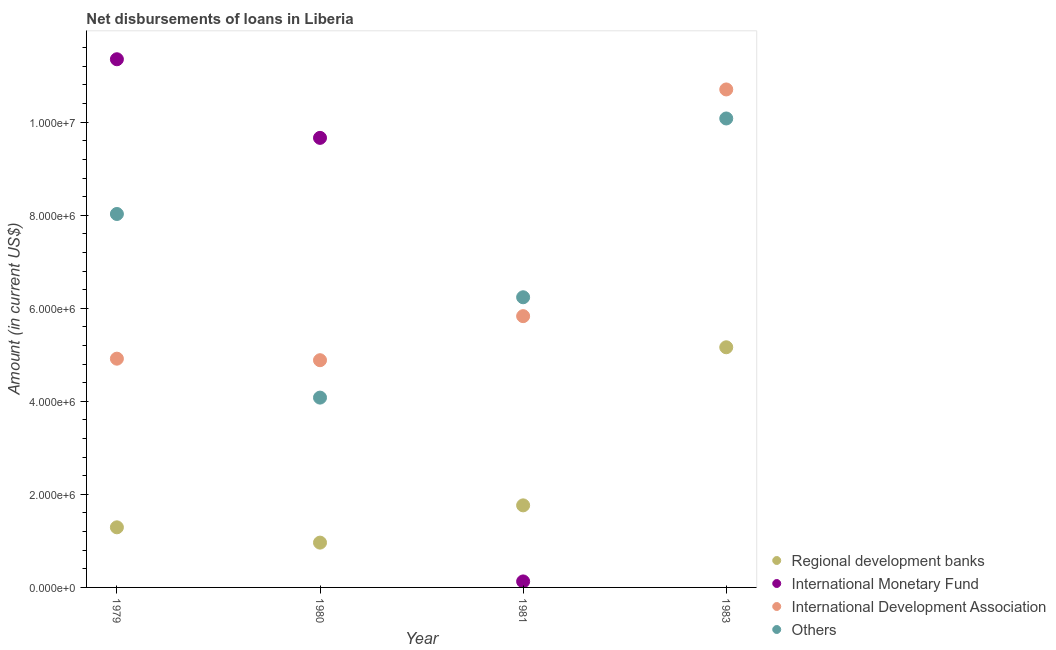Is the number of dotlines equal to the number of legend labels?
Provide a short and direct response. No. What is the amount of loan disimbursed by other organisations in 1981?
Make the answer very short. 6.24e+06. Across all years, what is the maximum amount of loan disimbursed by other organisations?
Provide a short and direct response. 1.01e+07. Across all years, what is the minimum amount of loan disimbursed by international development association?
Provide a short and direct response. 4.88e+06. What is the total amount of loan disimbursed by regional development banks in the graph?
Provide a short and direct response. 9.18e+06. What is the difference between the amount of loan disimbursed by international development association in 1979 and that in 1980?
Your response must be concise. 3.30e+04. What is the difference between the amount of loan disimbursed by other organisations in 1981 and the amount of loan disimbursed by international development association in 1983?
Make the answer very short. -4.47e+06. What is the average amount of loan disimbursed by regional development banks per year?
Your answer should be very brief. 2.30e+06. In the year 1981, what is the difference between the amount of loan disimbursed by regional development banks and amount of loan disimbursed by other organisations?
Make the answer very short. -4.47e+06. What is the ratio of the amount of loan disimbursed by other organisations in 1980 to that in 1981?
Provide a succinct answer. 0.65. Is the amount of loan disimbursed by regional development banks in 1979 less than that in 1981?
Your answer should be very brief. Yes. Is the difference between the amount of loan disimbursed by other organisations in 1980 and 1981 greater than the difference between the amount of loan disimbursed by international monetary fund in 1980 and 1981?
Make the answer very short. No. What is the difference between the highest and the second highest amount of loan disimbursed by international monetary fund?
Your response must be concise. 1.69e+06. What is the difference between the highest and the lowest amount of loan disimbursed by international development association?
Offer a terse response. 5.82e+06. In how many years, is the amount of loan disimbursed by other organisations greater than the average amount of loan disimbursed by other organisations taken over all years?
Make the answer very short. 2. Is it the case that in every year, the sum of the amount of loan disimbursed by international development association and amount of loan disimbursed by regional development banks is greater than the sum of amount of loan disimbursed by international monetary fund and amount of loan disimbursed by other organisations?
Provide a succinct answer. No. Does the amount of loan disimbursed by other organisations monotonically increase over the years?
Your answer should be very brief. No. What is the difference between two consecutive major ticks on the Y-axis?
Offer a very short reply. 2.00e+06. How are the legend labels stacked?
Offer a very short reply. Vertical. What is the title of the graph?
Provide a succinct answer. Net disbursements of loans in Liberia. Does "Subsidies and Transfers" appear as one of the legend labels in the graph?
Your response must be concise. No. What is the label or title of the X-axis?
Give a very brief answer. Year. What is the Amount (in current US$) of Regional development banks in 1979?
Your answer should be very brief. 1.29e+06. What is the Amount (in current US$) in International Monetary Fund in 1979?
Offer a terse response. 1.14e+07. What is the Amount (in current US$) of International Development Association in 1979?
Your answer should be very brief. 4.92e+06. What is the Amount (in current US$) of Others in 1979?
Ensure brevity in your answer.  8.03e+06. What is the Amount (in current US$) in Regional development banks in 1980?
Make the answer very short. 9.63e+05. What is the Amount (in current US$) in International Monetary Fund in 1980?
Provide a short and direct response. 9.66e+06. What is the Amount (in current US$) in International Development Association in 1980?
Provide a short and direct response. 4.88e+06. What is the Amount (in current US$) in Others in 1980?
Give a very brief answer. 4.08e+06. What is the Amount (in current US$) in Regional development banks in 1981?
Make the answer very short. 1.76e+06. What is the Amount (in current US$) in International Monetary Fund in 1981?
Your response must be concise. 1.29e+05. What is the Amount (in current US$) of International Development Association in 1981?
Your answer should be compact. 5.83e+06. What is the Amount (in current US$) of Others in 1981?
Keep it short and to the point. 6.24e+06. What is the Amount (in current US$) of Regional development banks in 1983?
Make the answer very short. 5.16e+06. What is the Amount (in current US$) of International Monetary Fund in 1983?
Ensure brevity in your answer.  0. What is the Amount (in current US$) of International Development Association in 1983?
Your answer should be compact. 1.07e+07. What is the Amount (in current US$) in Others in 1983?
Give a very brief answer. 1.01e+07. Across all years, what is the maximum Amount (in current US$) of Regional development banks?
Make the answer very short. 5.16e+06. Across all years, what is the maximum Amount (in current US$) of International Monetary Fund?
Keep it short and to the point. 1.14e+07. Across all years, what is the maximum Amount (in current US$) in International Development Association?
Provide a short and direct response. 1.07e+07. Across all years, what is the maximum Amount (in current US$) of Others?
Keep it short and to the point. 1.01e+07. Across all years, what is the minimum Amount (in current US$) of Regional development banks?
Your answer should be compact. 9.63e+05. Across all years, what is the minimum Amount (in current US$) in International Development Association?
Keep it short and to the point. 4.88e+06. Across all years, what is the minimum Amount (in current US$) in Others?
Provide a succinct answer. 4.08e+06. What is the total Amount (in current US$) of Regional development banks in the graph?
Offer a terse response. 9.18e+06. What is the total Amount (in current US$) of International Monetary Fund in the graph?
Provide a succinct answer. 2.11e+07. What is the total Amount (in current US$) in International Development Association in the graph?
Your answer should be compact. 2.63e+07. What is the total Amount (in current US$) of Others in the graph?
Offer a very short reply. 2.84e+07. What is the difference between the Amount (in current US$) in Regional development banks in 1979 and that in 1980?
Your response must be concise. 3.29e+05. What is the difference between the Amount (in current US$) of International Monetary Fund in 1979 and that in 1980?
Provide a succinct answer. 1.69e+06. What is the difference between the Amount (in current US$) of International Development Association in 1979 and that in 1980?
Make the answer very short. 3.30e+04. What is the difference between the Amount (in current US$) of Others in 1979 and that in 1980?
Ensure brevity in your answer.  3.95e+06. What is the difference between the Amount (in current US$) of Regional development banks in 1979 and that in 1981?
Offer a terse response. -4.72e+05. What is the difference between the Amount (in current US$) in International Monetary Fund in 1979 and that in 1981?
Provide a succinct answer. 1.12e+07. What is the difference between the Amount (in current US$) in International Development Association in 1979 and that in 1981?
Your answer should be very brief. -9.14e+05. What is the difference between the Amount (in current US$) of Others in 1979 and that in 1981?
Your answer should be compact. 1.79e+06. What is the difference between the Amount (in current US$) of Regional development banks in 1979 and that in 1983?
Offer a terse response. -3.87e+06. What is the difference between the Amount (in current US$) in International Development Association in 1979 and that in 1983?
Keep it short and to the point. -5.79e+06. What is the difference between the Amount (in current US$) in Others in 1979 and that in 1983?
Offer a terse response. -2.05e+06. What is the difference between the Amount (in current US$) in Regional development banks in 1980 and that in 1981?
Ensure brevity in your answer.  -8.01e+05. What is the difference between the Amount (in current US$) of International Monetary Fund in 1980 and that in 1981?
Make the answer very short. 9.53e+06. What is the difference between the Amount (in current US$) of International Development Association in 1980 and that in 1981?
Provide a short and direct response. -9.47e+05. What is the difference between the Amount (in current US$) in Others in 1980 and that in 1981?
Your answer should be very brief. -2.16e+06. What is the difference between the Amount (in current US$) in Regional development banks in 1980 and that in 1983?
Your answer should be compact. -4.20e+06. What is the difference between the Amount (in current US$) of International Development Association in 1980 and that in 1983?
Make the answer very short. -5.82e+06. What is the difference between the Amount (in current US$) of Others in 1980 and that in 1983?
Your answer should be very brief. -6.00e+06. What is the difference between the Amount (in current US$) in Regional development banks in 1981 and that in 1983?
Your response must be concise. -3.40e+06. What is the difference between the Amount (in current US$) of International Development Association in 1981 and that in 1983?
Give a very brief answer. -4.87e+06. What is the difference between the Amount (in current US$) in Others in 1981 and that in 1983?
Your response must be concise. -3.84e+06. What is the difference between the Amount (in current US$) in Regional development banks in 1979 and the Amount (in current US$) in International Monetary Fund in 1980?
Provide a succinct answer. -8.37e+06. What is the difference between the Amount (in current US$) of Regional development banks in 1979 and the Amount (in current US$) of International Development Association in 1980?
Your response must be concise. -3.59e+06. What is the difference between the Amount (in current US$) in Regional development banks in 1979 and the Amount (in current US$) in Others in 1980?
Offer a very short reply. -2.79e+06. What is the difference between the Amount (in current US$) of International Monetary Fund in 1979 and the Amount (in current US$) of International Development Association in 1980?
Your answer should be compact. 6.47e+06. What is the difference between the Amount (in current US$) of International Monetary Fund in 1979 and the Amount (in current US$) of Others in 1980?
Your answer should be compact. 7.27e+06. What is the difference between the Amount (in current US$) of International Development Association in 1979 and the Amount (in current US$) of Others in 1980?
Make the answer very short. 8.37e+05. What is the difference between the Amount (in current US$) of Regional development banks in 1979 and the Amount (in current US$) of International Monetary Fund in 1981?
Make the answer very short. 1.16e+06. What is the difference between the Amount (in current US$) in Regional development banks in 1979 and the Amount (in current US$) in International Development Association in 1981?
Offer a terse response. -4.54e+06. What is the difference between the Amount (in current US$) of Regional development banks in 1979 and the Amount (in current US$) of Others in 1981?
Provide a succinct answer. -4.94e+06. What is the difference between the Amount (in current US$) in International Monetary Fund in 1979 and the Amount (in current US$) in International Development Association in 1981?
Keep it short and to the point. 5.52e+06. What is the difference between the Amount (in current US$) of International Monetary Fund in 1979 and the Amount (in current US$) of Others in 1981?
Ensure brevity in your answer.  5.12e+06. What is the difference between the Amount (in current US$) in International Development Association in 1979 and the Amount (in current US$) in Others in 1981?
Your answer should be compact. -1.32e+06. What is the difference between the Amount (in current US$) in Regional development banks in 1979 and the Amount (in current US$) in International Development Association in 1983?
Keep it short and to the point. -9.41e+06. What is the difference between the Amount (in current US$) of Regional development banks in 1979 and the Amount (in current US$) of Others in 1983?
Offer a very short reply. -8.79e+06. What is the difference between the Amount (in current US$) of International Monetary Fund in 1979 and the Amount (in current US$) of International Development Association in 1983?
Ensure brevity in your answer.  6.49e+05. What is the difference between the Amount (in current US$) of International Monetary Fund in 1979 and the Amount (in current US$) of Others in 1983?
Your response must be concise. 1.27e+06. What is the difference between the Amount (in current US$) in International Development Association in 1979 and the Amount (in current US$) in Others in 1983?
Give a very brief answer. -5.16e+06. What is the difference between the Amount (in current US$) of Regional development banks in 1980 and the Amount (in current US$) of International Monetary Fund in 1981?
Keep it short and to the point. 8.34e+05. What is the difference between the Amount (in current US$) in Regional development banks in 1980 and the Amount (in current US$) in International Development Association in 1981?
Ensure brevity in your answer.  -4.87e+06. What is the difference between the Amount (in current US$) of Regional development banks in 1980 and the Amount (in current US$) of Others in 1981?
Your answer should be compact. -5.27e+06. What is the difference between the Amount (in current US$) of International Monetary Fund in 1980 and the Amount (in current US$) of International Development Association in 1981?
Provide a short and direct response. 3.83e+06. What is the difference between the Amount (in current US$) in International Monetary Fund in 1980 and the Amount (in current US$) in Others in 1981?
Provide a succinct answer. 3.43e+06. What is the difference between the Amount (in current US$) in International Development Association in 1980 and the Amount (in current US$) in Others in 1981?
Ensure brevity in your answer.  -1.35e+06. What is the difference between the Amount (in current US$) of Regional development banks in 1980 and the Amount (in current US$) of International Development Association in 1983?
Make the answer very short. -9.74e+06. What is the difference between the Amount (in current US$) in Regional development banks in 1980 and the Amount (in current US$) in Others in 1983?
Provide a short and direct response. -9.12e+06. What is the difference between the Amount (in current US$) in International Monetary Fund in 1980 and the Amount (in current US$) in International Development Association in 1983?
Your answer should be very brief. -1.04e+06. What is the difference between the Amount (in current US$) in International Monetary Fund in 1980 and the Amount (in current US$) in Others in 1983?
Your answer should be compact. -4.17e+05. What is the difference between the Amount (in current US$) in International Development Association in 1980 and the Amount (in current US$) in Others in 1983?
Ensure brevity in your answer.  -5.20e+06. What is the difference between the Amount (in current US$) of Regional development banks in 1981 and the Amount (in current US$) of International Development Association in 1983?
Offer a very short reply. -8.94e+06. What is the difference between the Amount (in current US$) in Regional development banks in 1981 and the Amount (in current US$) in Others in 1983?
Offer a very short reply. -8.32e+06. What is the difference between the Amount (in current US$) in International Monetary Fund in 1981 and the Amount (in current US$) in International Development Association in 1983?
Keep it short and to the point. -1.06e+07. What is the difference between the Amount (in current US$) in International Monetary Fund in 1981 and the Amount (in current US$) in Others in 1983?
Provide a succinct answer. -9.95e+06. What is the difference between the Amount (in current US$) in International Development Association in 1981 and the Amount (in current US$) in Others in 1983?
Offer a very short reply. -4.25e+06. What is the average Amount (in current US$) of Regional development banks per year?
Your answer should be compact. 2.30e+06. What is the average Amount (in current US$) in International Monetary Fund per year?
Give a very brief answer. 5.29e+06. What is the average Amount (in current US$) of International Development Association per year?
Your answer should be very brief. 6.58e+06. What is the average Amount (in current US$) of Others per year?
Ensure brevity in your answer.  7.11e+06. In the year 1979, what is the difference between the Amount (in current US$) of Regional development banks and Amount (in current US$) of International Monetary Fund?
Give a very brief answer. -1.01e+07. In the year 1979, what is the difference between the Amount (in current US$) of Regional development banks and Amount (in current US$) of International Development Association?
Provide a succinct answer. -3.62e+06. In the year 1979, what is the difference between the Amount (in current US$) in Regional development banks and Amount (in current US$) in Others?
Offer a terse response. -6.74e+06. In the year 1979, what is the difference between the Amount (in current US$) in International Monetary Fund and Amount (in current US$) in International Development Association?
Provide a short and direct response. 6.44e+06. In the year 1979, what is the difference between the Amount (in current US$) in International Monetary Fund and Amount (in current US$) in Others?
Provide a short and direct response. 3.33e+06. In the year 1979, what is the difference between the Amount (in current US$) of International Development Association and Amount (in current US$) of Others?
Offer a very short reply. -3.11e+06. In the year 1980, what is the difference between the Amount (in current US$) in Regional development banks and Amount (in current US$) in International Monetary Fund?
Make the answer very short. -8.70e+06. In the year 1980, what is the difference between the Amount (in current US$) of Regional development banks and Amount (in current US$) of International Development Association?
Your answer should be very brief. -3.92e+06. In the year 1980, what is the difference between the Amount (in current US$) in Regional development banks and Amount (in current US$) in Others?
Keep it short and to the point. -3.12e+06. In the year 1980, what is the difference between the Amount (in current US$) in International Monetary Fund and Amount (in current US$) in International Development Association?
Provide a succinct answer. 4.78e+06. In the year 1980, what is the difference between the Amount (in current US$) in International Monetary Fund and Amount (in current US$) in Others?
Keep it short and to the point. 5.58e+06. In the year 1980, what is the difference between the Amount (in current US$) in International Development Association and Amount (in current US$) in Others?
Your response must be concise. 8.04e+05. In the year 1981, what is the difference between the Amount (in current US$) of Regional development banks and Amount (in current US$) of International Monetary Fund?
Provide a short and direct response. 1.64e+06. In the year 1981, what is the difference between the Amount (in current US$) in Regional development banks and Amount (in current US$) in International Development Association?
Your response must be concise. -4.07e+06. In the year 1981, what is the difference between the Amount (in current US$) in Regional development banks and Amount (in current US$) in Others?
Keep it short and to the point. -4.47e+06. In the year 1981, what is the difference between the Amount (in current US$) of International Monetary Fund and Amount (in current US$) of International Development Association?
Ensure brevity in your answer.  -5.70e+06. In the year 1981, what is the difference between the Amount (in current US$) of International Monetary Fund and Amount (in current US$) of Others?
Keep it short and to the point. -6.11e+06. In the year 1981, what is the difference between the Amount (in current US$) of International Development Association and Amount (in current US$) of Others?
Your response must be concise. -4.06e+05. In the year 1983, what is the difference between the Amount (in current US$) in Regional development banks and Amount (in current US$) in International Development Association?
Give a very brief answer. -5.54e+06. In the year 1983, what is the difference between the Amount (in current US$) of Regional development banks and Amount (in current US$) of Others?
Offer a terse response. -4.92e+06. In the year 1983, what is the difference between the Amount (in current US$) in International Development Association and Amount (in current US$) in Others?
Make the answer very short. 6.24e+05. What is the ratio of the Amount (in current US$) in Regional development banks in 1979 to that in 1980?
Provide a succinct answer. 1.34. What is the ratio of the Amount (in current US$) of International Monetary Fund in 1979 to that in 1980?
Provide a short and direct response. 1.17. What is the ratio of the Amount (in current US$) of International Development Association in 1979 to that in 1980?
Your answer should be very brief. 1.01. What is the ratio of the Amount (in current US$) in Others in 1979 to that in 1980?
Your answer should be compact. 1.97. What is the ratio of the Amount (in current US$) of Regional development banks in 1979 to that in 1981?
Ensure brevity in your answer.  0.73. What is the ratio of the Amount (in current US$) in International Monetary Fund in 1979 to that in 1981?
Make the answer very short. 88.01. What is the ratio of the Amount (in current US$) of International Development Association in 1979 to that in 1981?
Give a very brief answer. 0.84. What is the ratio of the Amount (in current US$) of Others in 1979 to that in 1981?
Provide a succinct answer. 1.29. What is the ratio of the Amount (in current US$) in Regional development banks in 1979 to that in 1983?
Make the answer very short. 0.25. What is the ratio of the Amount (in current US$) in International Development Association in 1979 to that in 1983?
Make the answer very short. 0.46. What is the ratio of the Amount (in current US$) of Others in 1979 to that in 1983?
Your response must be concise. 0.8. What is the ratio of the Amount (in current US$) in Regional development banks in 1980 to that in 1981?
Your answer should be compact. 0.55. What is the ratio of the Amount (in current US$) of International Monetary Fund in 1980 to that in 1981?
Ensure brevity in your answer.  74.91. What is the ratio of the Amount (in current US$) in International Development Association in 1980 to that in 1981?
Your answer should be compact. 0.84. What is the ratio of the Amount (in current US$) of Others in 1980 to that in 1981?
Give a very brief answer. 0.65. What is the ratio of the Amount (in current US$) of Regional development banks in 1980 to that in 1983?
Provide a short and direct response. 0.19. What is the ratio of the Amount (in current US$) in International Development Association in 1980 to that in 1983?
Keep it short and to the point. 0.46. What is the ratio of the Amount (in current US$) in Others in 1980 to that in 1983?
Make the answer very short. 0.4. What is the ratio of the Amount (in current US$) in Regional development banks in 1981 to that in 1983?
Your response must be concise. 0.34. What is the ratio of the Amount (in current US$) in International Development Association in 1981 to that in 1983?
Your answer should be compact. 0.54. What is the ratio of the Amount (in current US$) of Others in 1981 to that in 1983?
Your answer should be compact. 0.62. What is the difference between the highest and the second highest Amount (in current US$) of Regional development banks?
Ensure brevity in your answer.  3.40e+06. What is the difference between the highest and the second highest Amount (in current US$) in International Monetary Fund?
Provide a short and direct response. 1.69e+06. What is the difference between the highest and the second highest Amount (in current US$) in International Development Association?
Offer a very short reply. 4.87e+06. What is the difference between the highest and the second highest Amount (in current US$) of Others?
Give a very brief answer. 2.05e+06. What is the difference between the highest and the lowest Amount (in current US$) of Regional development banks?
Provide a short and direct response. 4.20e+06. What is the difference between the highest and the lowest Amount (in current US$) of International Monetary Fund?
Your answer should be compact. 1.14e+07. What is the difference between the highest and the lowest Amount (in current US$) of International Development Association?
Offer a very short reply. 5.82e+06. 